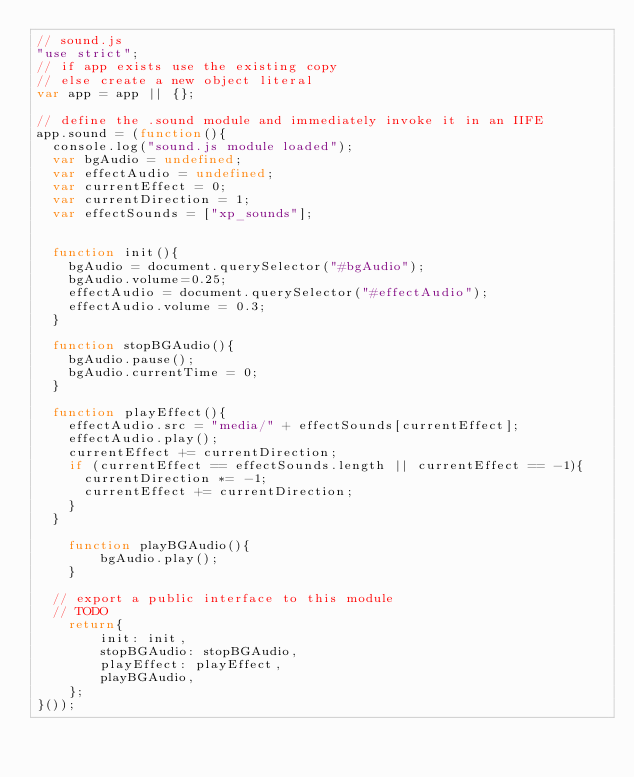Convert code to text. <code><loc_0><loc_0><loc_500><loc_500><_JavaScript_>// sound.js
"use strict";
// if app exists use the existing copy
// else create a new object literal
var app = app || {};

// define the .sound module and immediately invoke it in an IIFE
app.sound = (function(){
	console.log("sound.js module loaded");
	var bgAudio = undefined;
	var effectAudio = undefined;
	var currentEffect = 0;
	var currentDirection = 1;
	var effectSounds = ["xp_sounds"];
	

	function init(){
		bgAudio = document.querySelector("#bgAudio");
		bgAudio.volume=0.25;
		effectAudio = document.querySelector("#effectAudio");
		effectAudio.volume = 0.3;
	}
		
	function stopBGAudio(){
		bgAudio.pause();
		bgAudio.currentTime = 0;
	}
	
	function playEffect(){
		effectAudio.src = "media/" + effectSounds[currentEffect];
		effectAudio.play();
		currentEffect += currentDirection;
		if (currentEffect == effectSounds.length || currentEffect == -1){
			currentDirection *= -1;
			currentEffect += currentDirection;
		}
	}
    
    function playBGAudio(){
        bgAudio.play();
    }
		
	// export a public interface to this module
	// TODO
    return{
        init: init,
        stopBGAudio: stopBGAudio,
        playEffect: playEffect,
        playBGAudio,
    };
}());</code> 